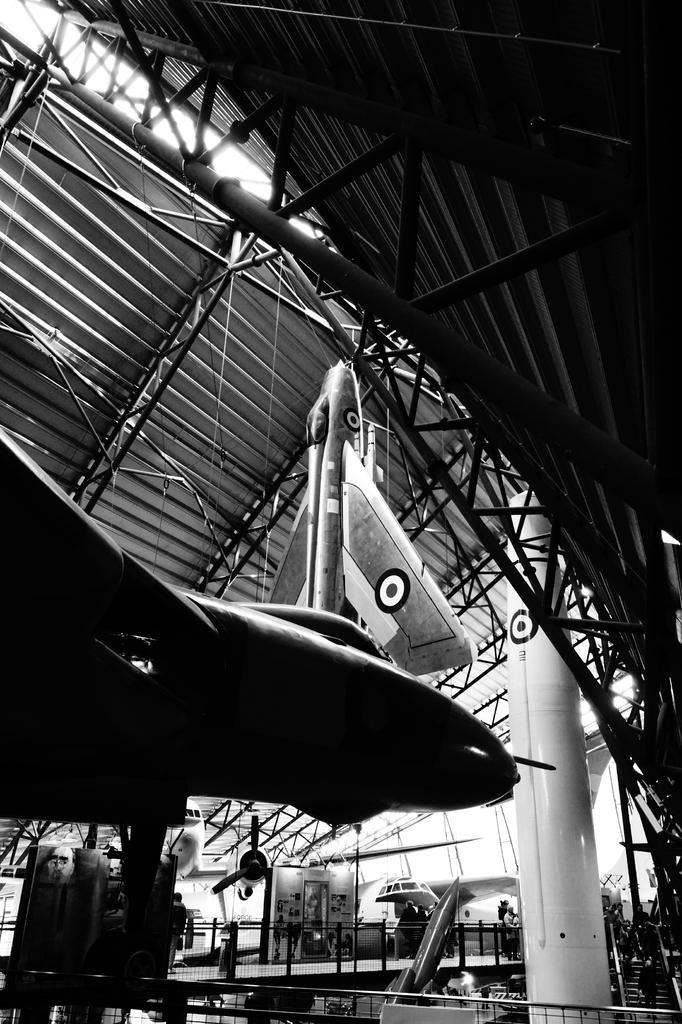In one or two sentences, can you explain what this image depicts? In this image there are aircrafts and rockets in a metal shed supported by rods. 